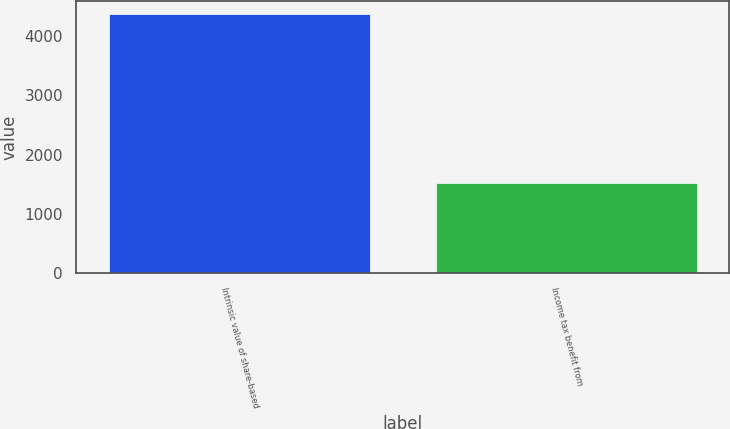Convert chart. <chart><loc_0><loc_0><loc_500><loc_500><bar_chart><fcel>Intrinsic value of share-based<fcel>Income tax benefit from<nl><fcel>4377<fcel>1521<nl></chart> 